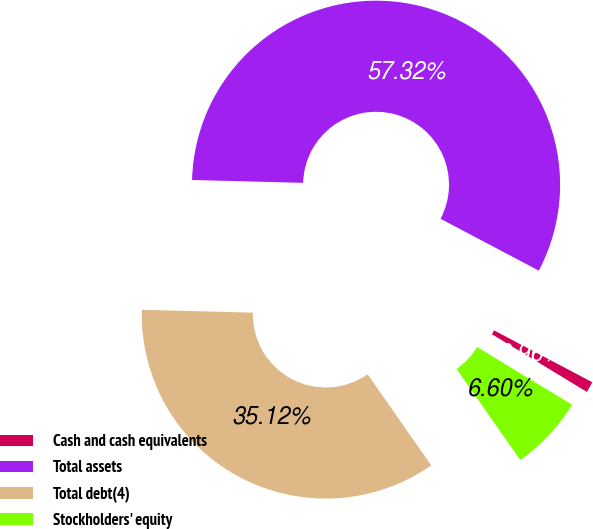<chart> <loc_0><loc_0><loc_500><loc_500><pie_chart><fcel>Cash and cash equivalents<fcel>Total assets<fcel>Total debt(4)<fcel>Stockholders' equity<nl><fcel>0.96%<fcel>57.32%<fcel>35.12%<fcel>6.6%<nl></chart> 